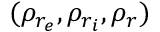Convert formula to latex. <formula><loc_0><loc_0><loc_500><loc_500>( \rho _ { r _ { e } } , \rho _ { r _ { i } } , \rho _ { r } )</formula> 